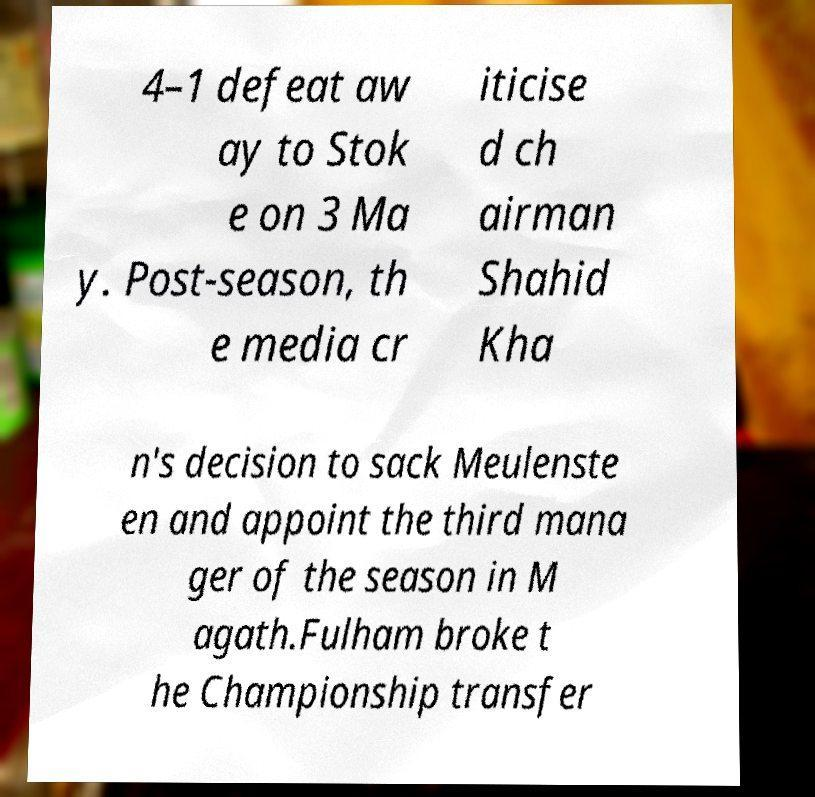Can you accurately transcribe the text from the provided image for me? 4–1 defeat aw ay to Stok e on 3 Ma y. Post-season, th e media cr iticise d ch airman Shahid Kha n's decision to sack Meulenste en and appoint the third mana ger of the season in M agath.Fulham broke t he Championship transfer 